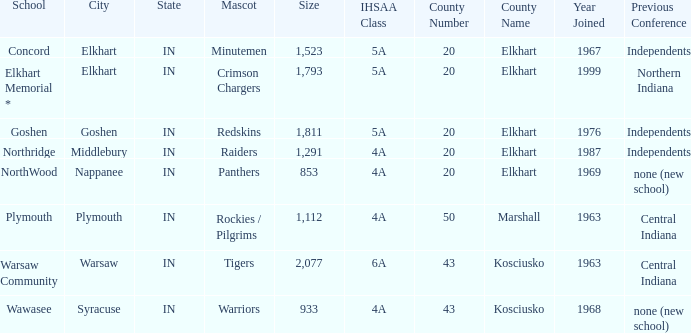What is the IHSAA class for the team located in Middlebury, IN? 4A. 